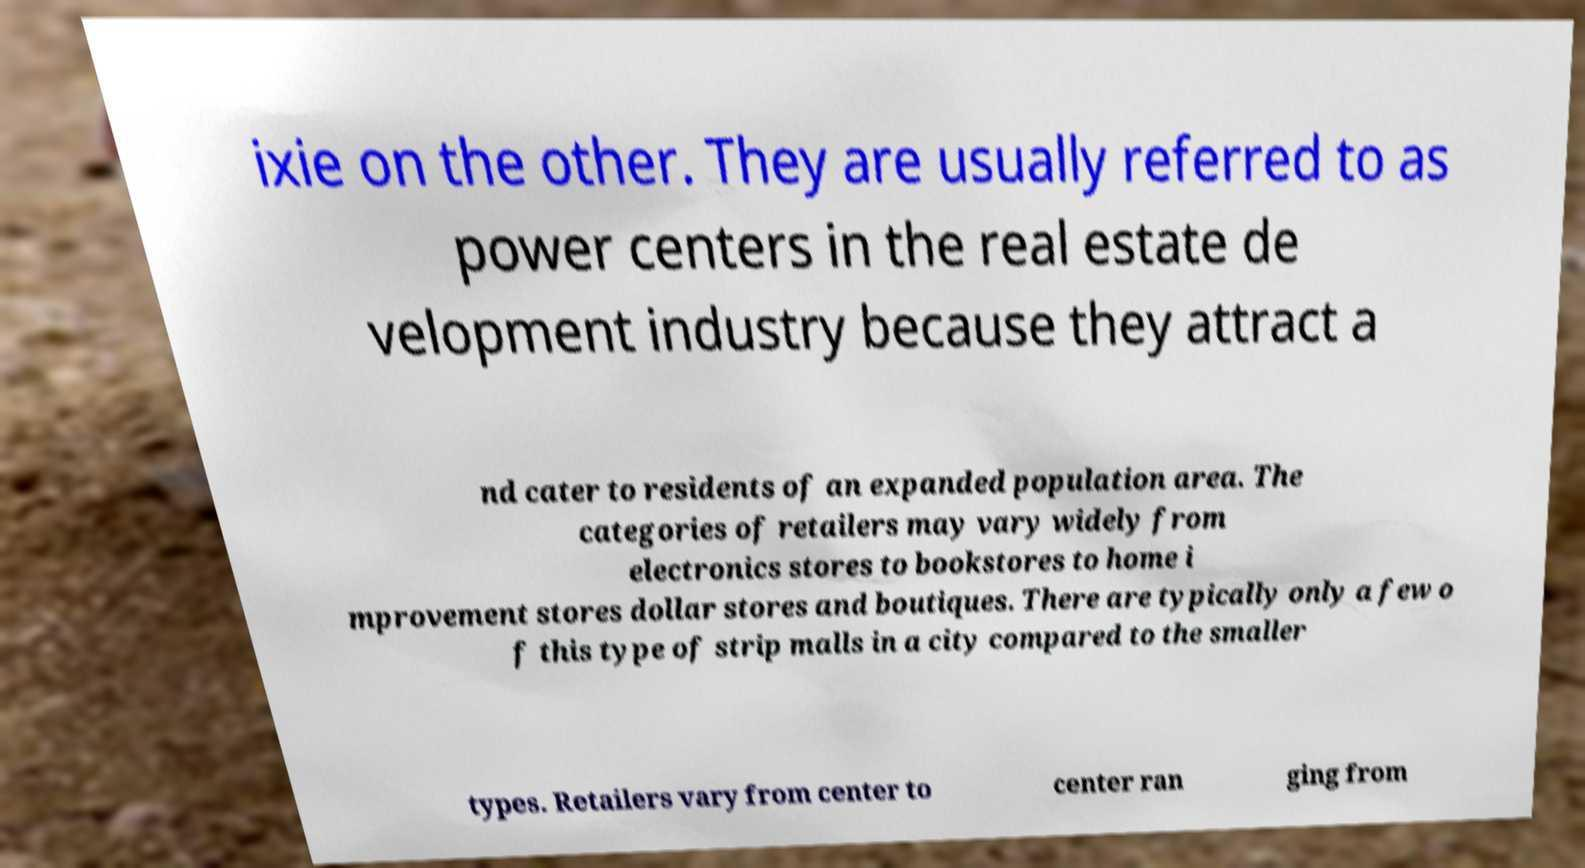Can you read and provide the text displayed in the image?This photo seems to have some interesting text. Can you extract and type it out for me? ixie on the other. They are usually referred to as power centers in the real estate de velopment industry because they attract a nd cater to residents of an expanded population area. The categories of retailers may vary widely from electronics stores to bookstores to home i mprovement stores dollar stores and boutiques. There are typically only a few o f this type of strip malls in a city compared to the smaller types. Retailers vary from center to center ran ging from 